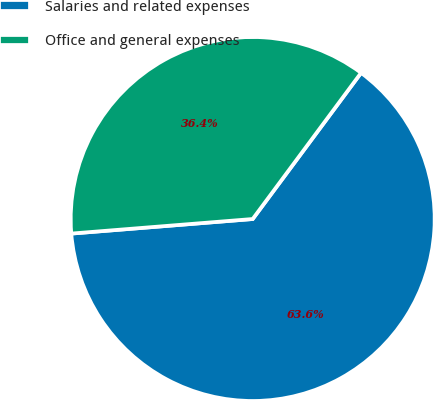Convert chart. <chart><loc_0><loc_0><loc_500><loc_500><pie_chart><fcel>Salaries and related expenses<fcel>Office and general expenses<nl><fcel>63.57%<fcel>36.43%<nl></chart> 